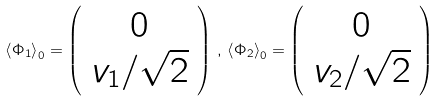<formula> <loc_0><loc_0><loc_500><loc_500>\left \langle \Phi _ { 1 } \right \rangle _ { 0 } = \left ( \begin{array} { c } 0 \\ v _ { 1 } / \sqrt { 2 } \end{array} \right ) \, , \, \left \langle \Phi _ { 2 } \right \rangle _ { 0 } = \left ( \begin{array} { c } 0 \\ v _ { 2 } / \sqrt { 2 } \end{array} \right )</formula> 